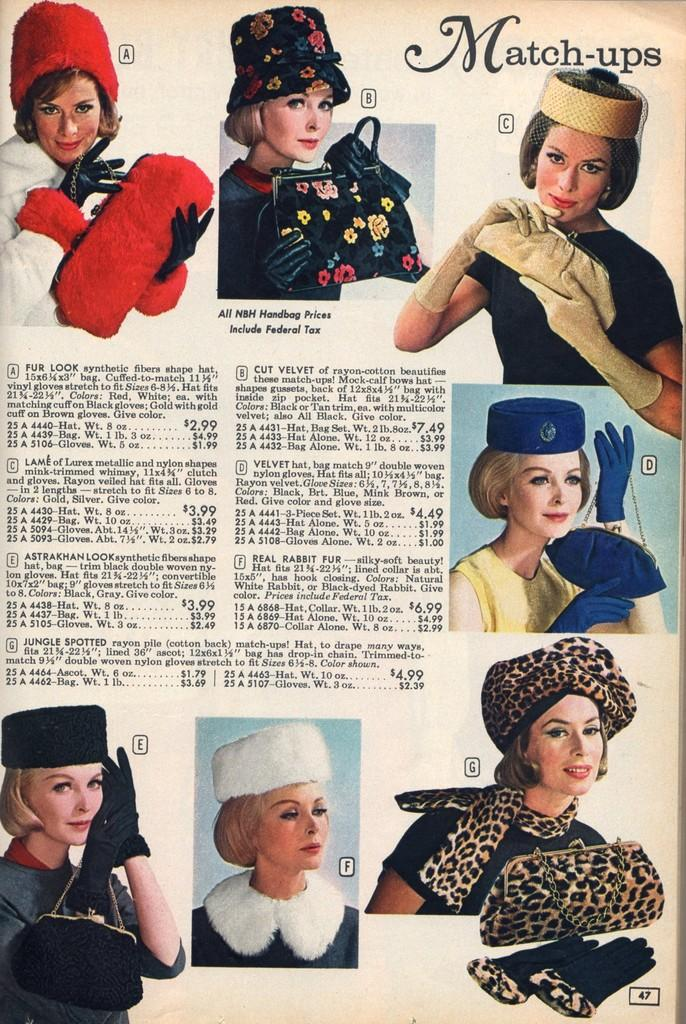What is the main subject of the paper in the image? The paper contains a depiction of a woman. What is the woman doing in the image? The woman is shown in different costumes. How many kittens are playing with the quartz in the image? There are no kittens or quartz present in the image. What type of bomb is shown in the image? There is no bomb present in the image. 